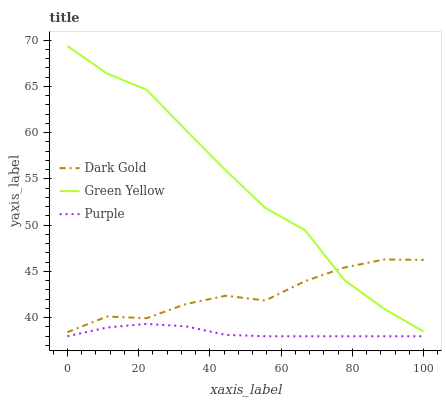Does Purple have the minimum area under the curve?
Answer yes or no. Yes. Does Green Yellow have the maximum area under the curve?
Answer yes or no. Yes. Does Dark Gold have the minimum area under the curve?
Answer yes or no. No. Does Dark Gold have the maximum area under the curve?
Answer yes or no. No. Is Purple the smoothest?
Answer yes or no. Yes. Is Green Yellow the roughest?
Answer yes or no. Yes. Is Dark Gold the smoothest?
Answer yes or no. No. Is Dark Gold the roughest?
Answer yes or no. No. Does Purple have the lowest value?
Answer yes or no. Yes. Does Dark Gold have the lowest value?
Answer yes or no. No. Does Green Yellow have the highest value?
Answer yes or no. Yes. Does Dark Gold have the highest value?
Answer yes or no. No. Is Purple less than Green Yellow?
Answer yes or no. Yes. Is Dark Gold greater than Purple?
Answer yes or no. Yes. Does Green Yellow intersect Dark Gold?
Answer yes or no. Yes. Is Green Yellow less than Dark Gold?
Answer yes or no. No. Is Green Yellow greater than Dark Gold?
Answer yes or no. No. Does Purple intersect Green Yellow?
Answer yes or no. No. 